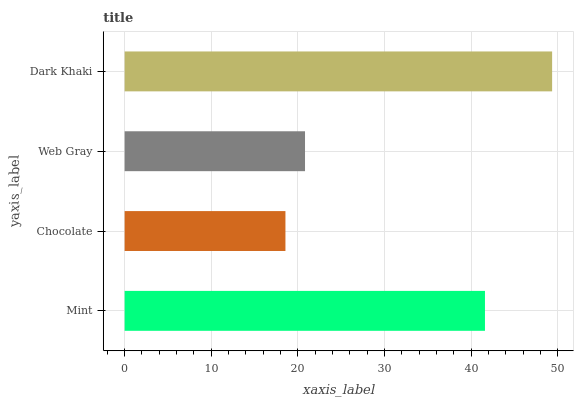Is Chocolate the minimum?
Answer yes or no. Yes. Is Dark Khaki the maximum?
Answer yes or no. Yes. Is Web Gray the minimum?
Answer yes or no. No. Is Web Gray the maximum?
Answer yes or no. No. Is Web Gray greater than Chocolate?
Answer yes or no. Yes. Is Chocolate less than Web Gray?
Answer yes or no. Yes. Is Chocolate greater than Web Gray?
Answer yes or no. No. Is Web Gray less than Chocolate?
Answer yes or no. No. Is Mint the high median?
Answer yes or no. Yes. Is Web Gray the low median?
Answer yes or no. Yes. Is Chocolate the high median?
Answer yes or no. No. Is Chocolate the low median?
Answer yes or no. No. 